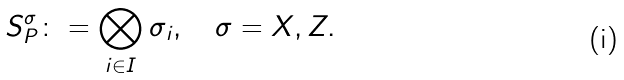Convert formula to latex. <formula><loc_0><loc_0><loc_500><loc_500>S _ { P } ^ { \sigma } \colon = \bigotimes _ { i \in I } \sigma _ { i } , \quad \sigma = X , Z .</formula> 